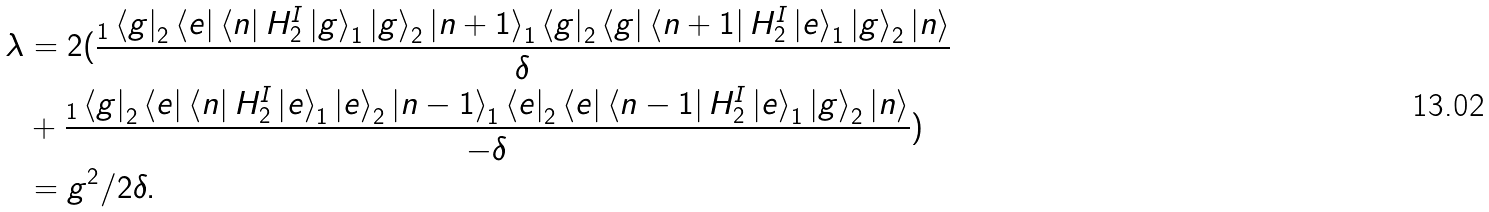Convert formula to latex. <formula><loc_0><loc_0><loc_500><loc_500>\lambda & = 2 ( \frac { _ { 1 } \left \langle g \right | _ { 2 } \left \langle e \right | \left \langle n \right | H _ { 2 } ^ { I } \left | g \right \rangle _ { 1 } \left | g \right \rangle _ { 2 } \left | n + 1 \right \rangle _ { 1 } \left \langle g \right | _ { 2 } \left \langle g \right | \left \langle n + 1 \right | H _ { 2 } ^ { I } \left | e \right \rangle _ { 1 } \left | g \right \rangle _ { 2 } \left | n \right \rangle } { \delta } \\ & + \frac { _ { 1 } \left \langle g \right | _ { 2 } \left \langle e \right | \left \langle n \right | H _ { 2 } ^ { I } \left | e \right \rangle _ { 1 } \left | e \right \rangle _ { 2 } \left | n - 1 \right \rangle _ { 1 } \left \langle e \right | _ { 2 } \left \langle e \right | \left \langle n - 1 \right | H _ { 2 } ^ { I } \left | e \right \rangle _ { 1 } \left | g \right \rangle _ { 2 } \left | n \right \rangle } { - \delta } ) \\ & = g ^ { 2 } / 2 \delta .</formula> 